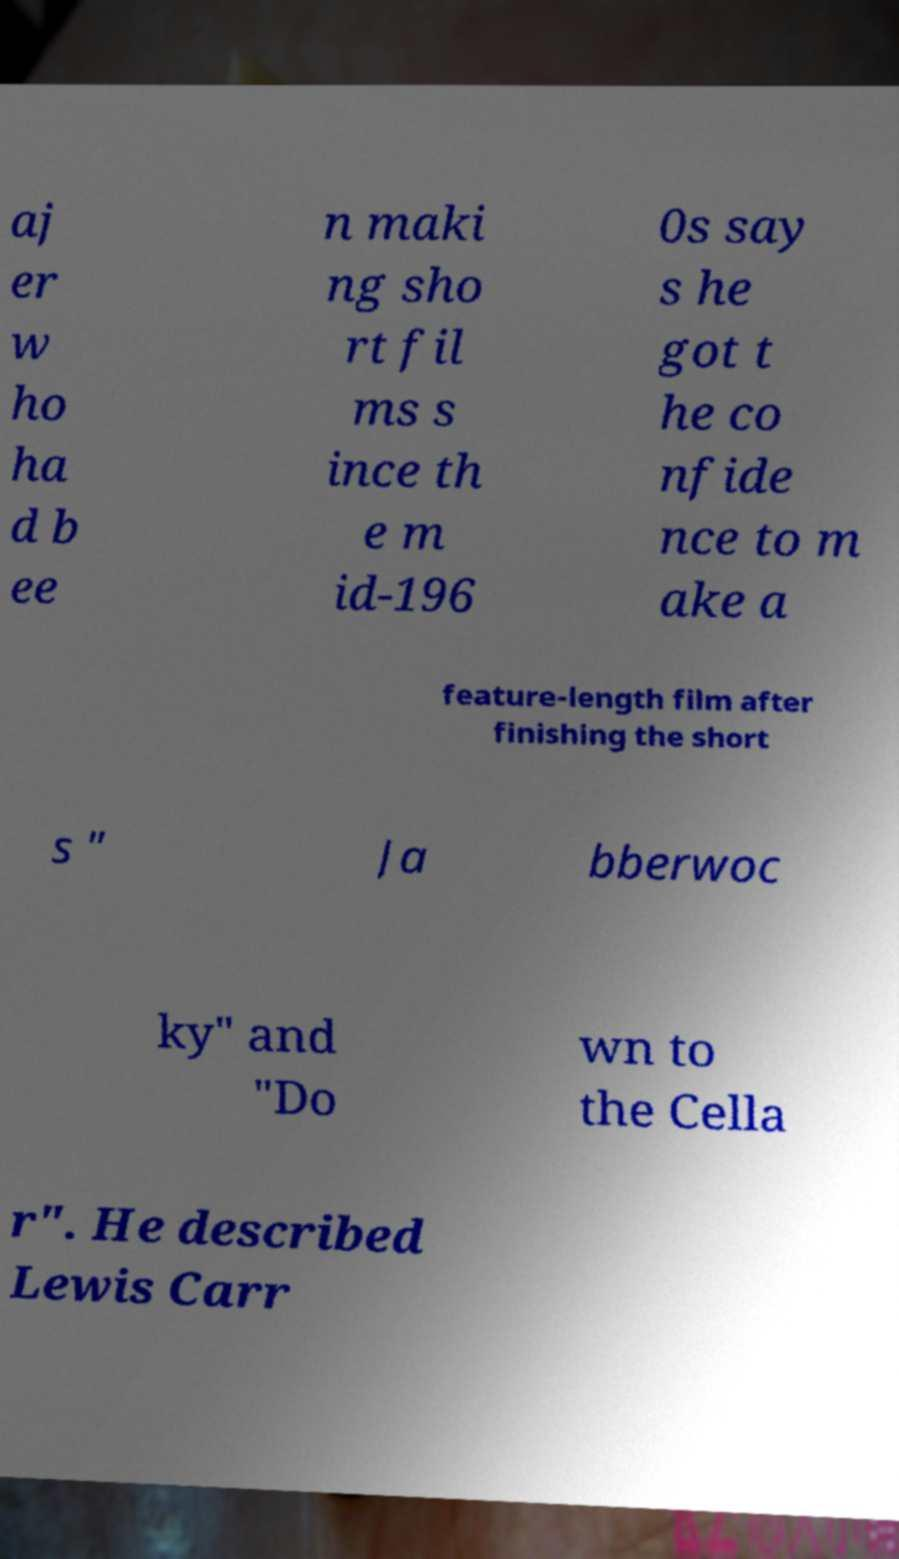There's text embedded in this image that I need extracted. Can you transcribe it verbatim? aj er w ho ha d b ee n maki ng sho rt fil ms s ince th e m id-196 0s say s he got t he co nfide nce to m ake a feature-length film after finishing the short s " Ja bberwoc ky" and "Do wn to the Cella r". He described Lewis Carr 